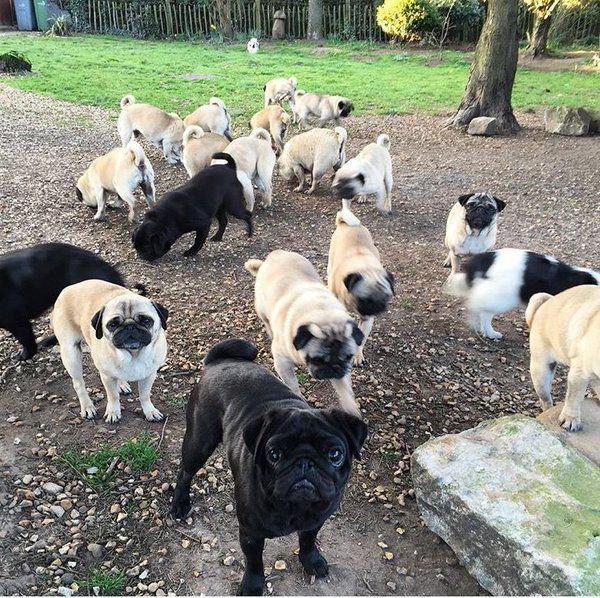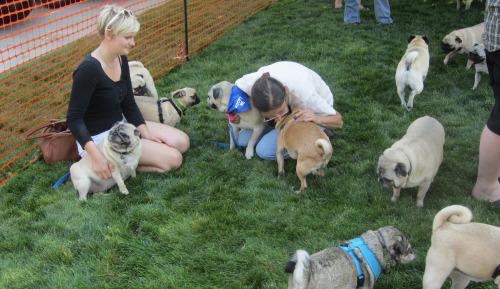The first image is the image on the left, the second image is the image on the right. Given the left and right images, does the statement "At least one image shows a group of pugs running toward the camera on grass." hold true? Answer yes or no. No. The first image is the image on the left, the second image is the image on the right. Assess this claim about the two images: "People are seen with the dogs on the left.". Correct or not? Answer yes or no. No. 